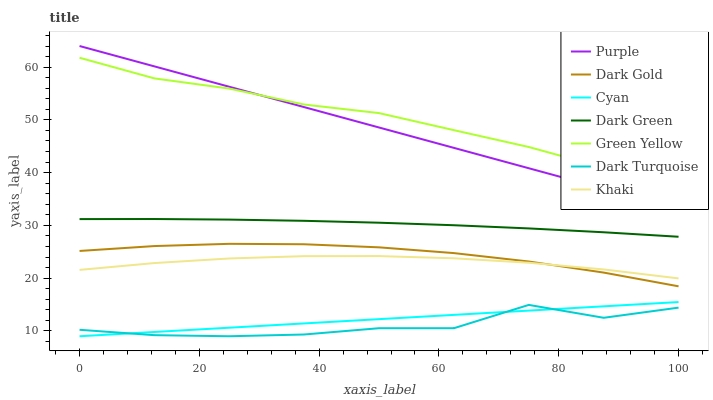Does Dark Turquoise have the minimum area under the curve?
Answer yes or no. Yes. Does Green Yellow have the maximum area under the curve?
Answer yes or no. Yes. Does Dark Gold have the minimum area under the curve?
Answer yes or no. No. Does Dark Gold have the maximum area under the curve?
Answer yes or no. No. Is Purple the smoothest?
Answer yes or no. Yes. Is Dark Turquoise the roughest?
Answer yes or no. Yes. Is Dark Gold the smoothest?
Answer yes or no. No. Is Dark Gold the roughest?
Answer yes or no. No. Does Dark Turquoise have the lowest value?
Answer yes or no. Yes. Does Dark Gold have the lowest value?
Answer yes or no. No. Does Purple have the highest value?
Answer yes or no. Yes. Does Dark Gold have the highest value?
Answer yes or no. No. Is Dark Turquoise less than Dark Gold?
Answer yes or no. Yes. Is Dark Green greater than Cyan?
Answer yes or no. Yes. Does Khaki intersect Dark Gold?
Answer yes or no. Yes. Is Khaki less than Dark Gold?
Answer yes or no. No. Is Khaki greater than Dark Gold?
Answer yes or no. No. Does Dark Turquoise intersect Dark Gold?
Answer yes or no. No. 